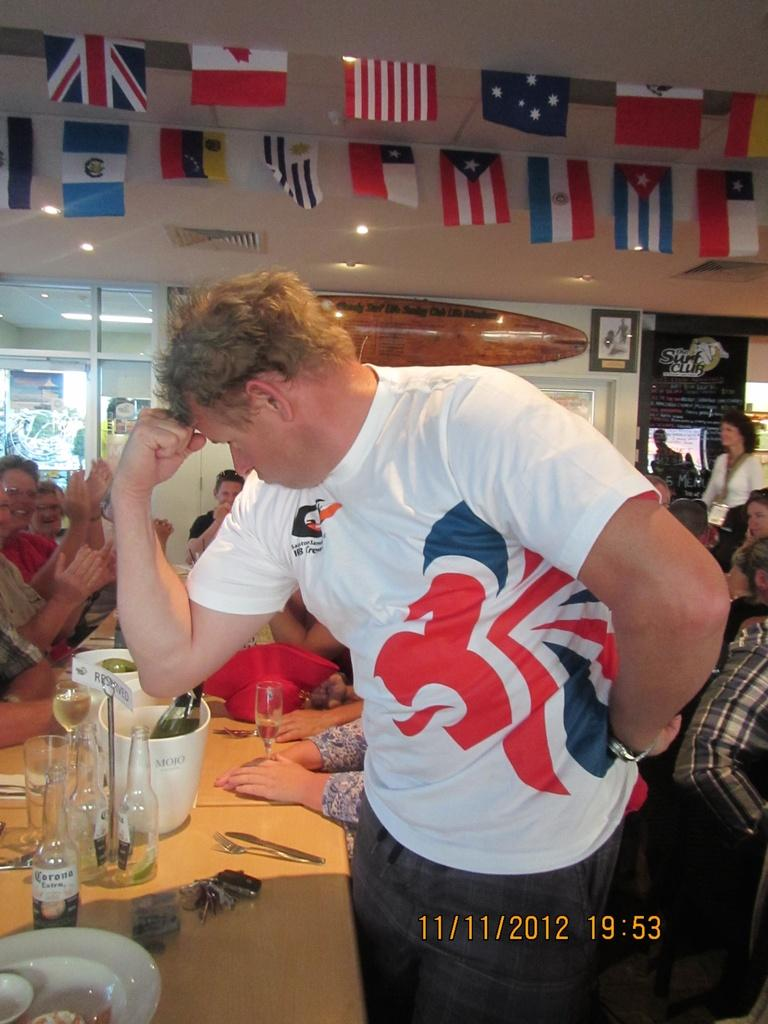<image>
Create a compact narrative representing the image presented. the picture is taken on November 11, 2012 